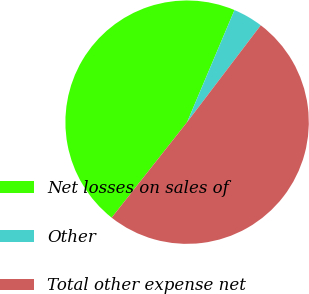Convert chart. <chart><loc_0><loc_0><loc_500><loc_500><pie_chart><fcel>Net losses on sales of<fcel>Other<fcel>Total other expense net<nl><fcel>45.72%<fcel>3.98%<fcel>50.29%<nl></chart> 